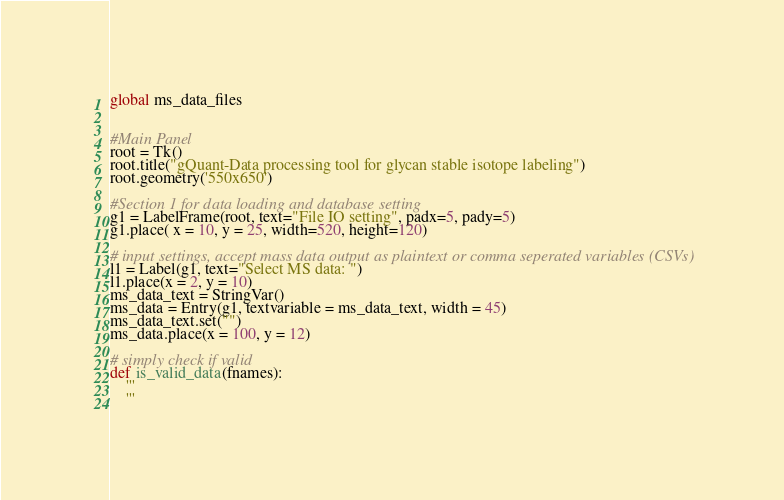Convert code to text. <code><loc_0><loc_0><loc_500><loc_500><_Python_>
global ms_data_files


#Main Panel
root = Tk()
root.title("gQuant-Data processing tool for glycan stable isotope labeling")
root.geometry('550x650')

#Section 1 for data loading and database setting
g1 = LabelFrame(root, text="File IO setting", padx=5, pady=5)
g1.place( x = 10, y = 25, width=520, height=120)

# input settings, accept mass data output as plaintext or comma seperated variables (CSVs)
l1 = Label(g1, text="Select MS data: ")
l1.place(x = 2, y = 10)
ms_data_text = StringVar()
ms_data = Entry(g1, textvariable = ms_data_text, width = 45)
ms_data_text.set("")
ms_data.place(x = 100, y = 12)

# simply check if valid
def is_valid_data(fnames):
    '''
    '''</code> 